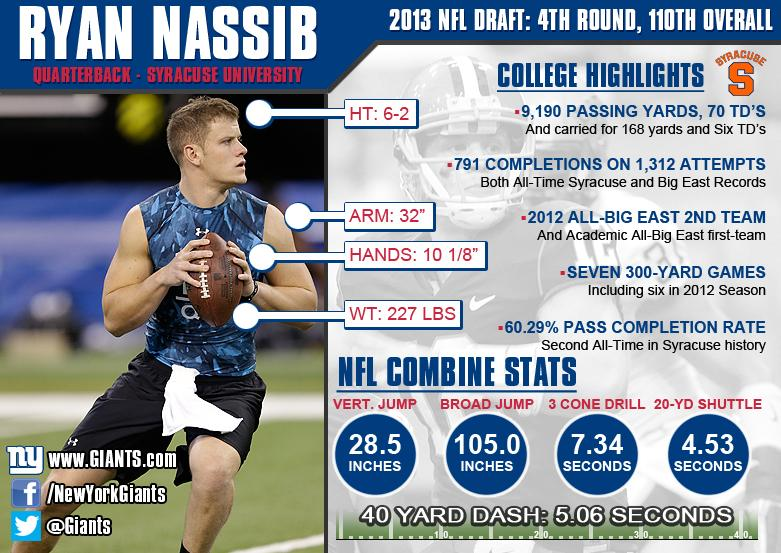Indicate a few pertinent items in this graphic. Ryan Nassib achieved a broad jump measurement of 105.0 inches, a testament to his exceptional athleticism and physical ability. The 20-yard shuttle measurement is 4.53 seconds. The weight of the player, as per the infographic, is 227 lbs. The team's Twitter handle mentioned in the infographic is @Giants, indicating the team's official social media presence. The NFL combine statistics show a vertical jump score of 28.5 for an individual. 